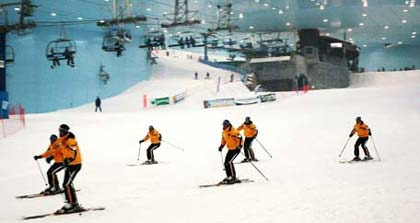Given that skiing requires certain conditions, can you explain the likely reason there is skiing happening indoors? Skiing typically requires cold weather and snow. The fact that skiing is happening indoors in the image suggests that this might be an indoor skiing facility or a snow dome. Such facilities create controlled environments where artificial snow is produced and maintained, allowing people to enjoy skiing all year round, regardless of the external climate. 